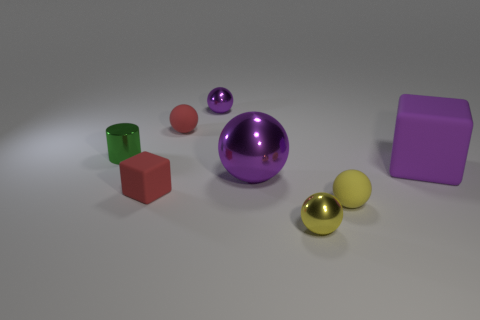Do the shiny object to the left of the tiny purple object and the shiny thing in front of the tiny red block have the same shape? Yes, they do. Both the shiny object to the left of the purple block and the object in front of the red block are spheres. They share the same geometrical shape despite the difference in their colors and sizes. 